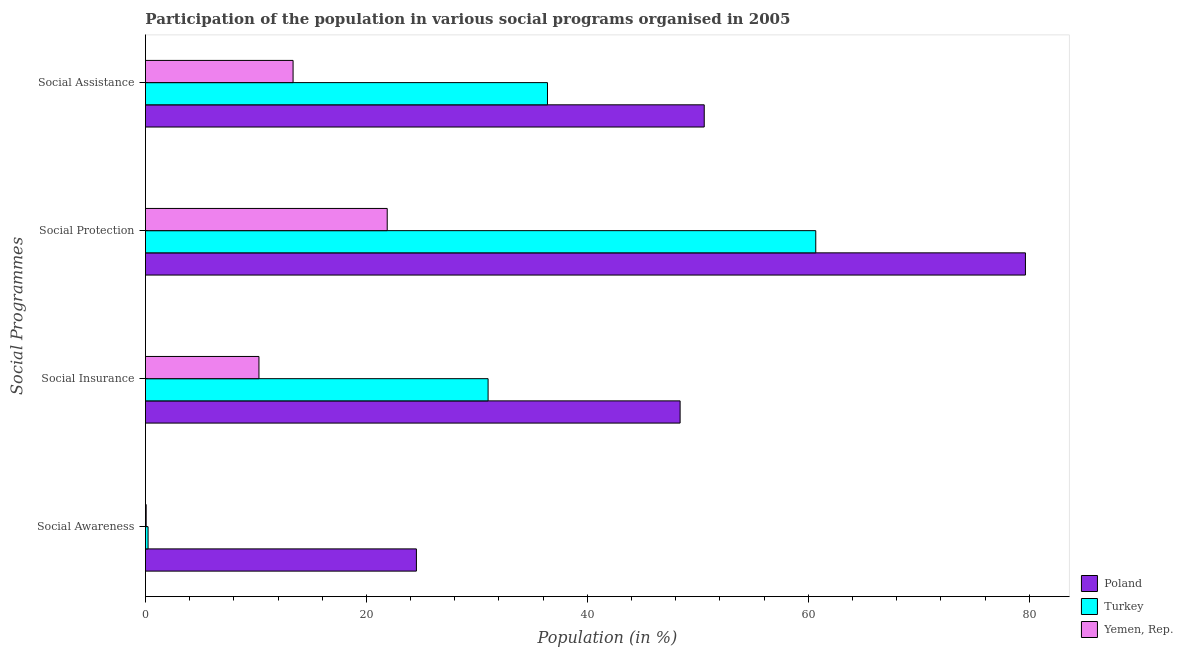How many different coloured bars are there?
Your answer should be compact. 3. How many bars are there on the 4th tick from the bottom?
Offer a terse response. 3. What is the label of the 3rd group of bars from the top?
Offer a very short reply. Social Insurance. What is the participation of population in social insurance programs in Yemen, Rep.?
Offer a terse response. 10.27. Across all countries, what is the maximum participation of population in social protection programs?
Offer a very short reply. 79.66. Across all countries, what is the minimum participation of population in social protection programs?
Your answer should be very brief. 21.88. In which country was the participation of population in social awareness programs maximum?
Offer a very short reply. Poland. In which country was the participation of population in social insurance programs minimum?
Give a very brief answer. Yemen, Rep. What is the total participation of population in social assistance programs in the graph?
Your response must be concise. 100.34. What is the difference between the participation of population in social protection programs in Turkey and that in Yemen, Rep.?
Offer a terse response. 38.79. What is the difference between the participation of population in social protection programs in Turkey and the participation of population in social assistance programs in Poland?
Offer a terse response. 10.1. What is the average participation of population in social protection programs per country?
Offer a very short reply. 54.07. What is the difference between the participation of population in social awareness programs and participation of population in social assistance programs in Turkey?
Your answer should be very brief. -36.15. What is the ratio of the participation of population in social protection programs in Yemen, Rep. to that in Poland?
Make the answer very short. 0.27. Is the participation of population in social protection programs in Turkey less than that in Yemen, Rep.?
Provide a short and direct response. No. Is the difference between the participation of population in social insurance programs in Yemen, Rep. and Turkey greater than the difference between the participation of population in social awareness programs in Yemen, Rep. and Turkey?
Make the answer very short. No. What is the difference between the highest and the second highest participation of population in social protection programs?
Give a very brief answer. 18.98. What is the difference between the highest and the lowest participation of population in social assistance programs?
Make the answer very short. 37.22. In how many countries, is the participation of population in social assistance programs greater than the average participation of population in social assistance programs taken over all countries?
Provide a short and direct response. 2. Is the sum of the participation of population in social protection programs in Yemen, Rep. and Turkey greater than the maximum participation of population in social insurance programs across all countries?
Provide a succinct answer. Yes. What does the 1st bar from the top in Social Insurance represents?
Provide a succinct answer. Yemen, Rep. What does the 1st bar from the bottom in Social Awareness represents?
Your response must be concise. Poland. Is it the case that in every country, the sum of the participation of population in social awareness programs and participation of population in social insurance programs is greater than the participation of population in social protection programs?
Ensure brevity in your answer.  No. How many bars are there?
Provide a succinct answer. 12. Does the graph contain grids?
Provide a succinct answer. No. Where does the legend appear in the graph?
Keep it short and to the point. Bottom right. How are the legend labels stacked?
Ensure brevity in your answer.  Vertical. What is the title of the graph?
Your response must be concise. Participation of the population in various social programs organised in 2005. Does "Zambia" appear as one of the legend labels in the graph?
Keep it short and to the point. No. What is the label or title of the X-axis?
Ensure brevity in your answer.  Population (in %). What is the label or title of the Y-axis?
Offer a terse response. Social Programmes. What is the Population (in %) of Poland in Social Awareness?
Your answer should be compact. 24.53. What is the Population (in %) in Turkey in Social Awareness?
Give a very brief answer. 0.24. What is the Population (in %) in Yemen, Rep. in Social Awareness?
Keep it short and to the point. 0.07. What is the Population (in %) in Poland in Social Insurance?
Keep it short and to the point. 48.4. What is the Population (in %) in Turkey in Social Insurance?
Provide a succinct answer. 31.02. What is the Population (in %) of Yemen, Rep. in Social Insurance?
Provide a short and direct response. 10.27. What is the Population (in %) of Poland in Social Protection?
Offer a terse response. 79.66. What is the Population (in %) in Turkey in Social Protection?
Your answer should be very brief. 60.68. What is the Population (in %) of Yemen, Rep. in Social Protection?
Your answer should be compact. 21.88. What is the Population (in %) of Poland in Social Assistance?
Offer a terse response. 50.58. What is the Population (in %) in Turkey in Social Assistance?
Offer a very short reply. 36.39. What is the Population (in %) of Yemen, Rep. in Social Assistance?
Your response must be concise. 13.36. Across all Social Programmes, what is the maximum Population (in %) of Poland?
Offer a terse response. 79.66. Across all Social Programmes, what is the maximum Population (in %) in Turkey?
Provide a succinct answer. 60.68. Across all Social Programmes, what is the maximum Population (in %) of Yemen, Rep.?
Your answer should be very brief. 21.88. Across all Social Programmes, what is the minimum Population (in %) of Poland?
Make the answer very short. 24.53. Across all Social Programmes, what is the minimum Population (in %) in Turkey?
Your answer should be compact. 0.24. Across all Social Programmes, what is the minimum Population (in %) of Yemen, Rep.?
Your answer should be very brief. 0.07. What is the total Population (in %) of Poland in the graph?
Keep it short and to the point. 203.17. What is the total Population (in %) of Turkey in the graph?
Give a very brief answer. 128.33. What is the total Population (in %) in Yemen, Rep. in the graph?
Provide a succinct answer. 45.59. What is the difference between the Population (in %) in Poland in Social Awareness and that in Social Insurance?
Your answer should be very brief. -23.87. What is the difference between the Population (in %) of Turkey in Social Awareness and that in Social Insurance?
Make the answer very short. -30.78. What is the difference between the Population (in %) in Yemen, Rep. in Social Awareness and that in Social Insurance?
Your answer should be very brief. -10.21. What is the difference between the Population (in %) of Poland in Social Awareness and that in Social Protection?
Ensure brevity in your answer.  -55.13. What is the difference between the Population (in %) in Turkey in Social Awareness and that in Social Protection?
Give a very brief answer. -60.44. What is the difference between the Population (in %) in Yemen, Rep. in Social Awareness and that in Social Protection?
Provide a succinct answer. -21.82. What is the difference between the Population (in %) of Poland in Social Awareness and that in Social Assistance?
Provide a succinct answer. -26.06. What is the difference between the Population (in %) of Turkey in Social Awareness and that in Social Assistance?
Make the answer very short. -36.15. What is the difference between the Population (in %) in Yemen, Rep. in Social Awareness and that in Social Assistance?
Your answer should be compact. -13.3. What is the difference between the Population (in %) of Poland in Social Insurance and that in Social Protection?
Make the answer very short. -31.26. What is the difference between the Population (in %) of Turkey in Social Insurance and that in Social Protection?
Keep it short and to the point. -29.66. What is the difference between the Population (in %) in Yemen, Rep. in Social Insurance and that in Social Protection?
Offer a terse response. -11.61. What is the difference between the Population (in %) in Poland in Social Insurance and that in Social Assistance?
Offer a very short reply. -2.18. What is the difference between the Population (in %) of Turkey in Social Insurance and that in Social Assistance?
Offer a very short reply. -5.38. What is the difference between the Population (in %) of Yemen, Rep. in Social Insurance and that in Social Assistance?
Make the answer very short. -3.09. What is the difference between the Population (in %) of Poland in Social Protection and that in Social Assistance?
Ensure brevity in your answer.  29.08. What is the difference between the Population (in %) of Turkey in Social Protection and that in Social Assistance?
Your answer should be compact. 24.29. What is the difference between the Population (in %) in Yemen, Rep. in Social Protection and that in Social Assistance?
Your answer should be compact. 8.52. What is the difference between the Population (in %) in Poland in Social Awareness and the Population (in %) in Turkey in Social Insurance?
Provide a succinct answer. -6.49. What is the difference between the Population (in %) of Poland in Social Awareness and the Population (in %) of Yemen, Rep. in Social Insurance?
Your answer should be compact. 14.25. What is the difference between the Population (in %) of Turkey in Social Awareness and the Population (in %) of Yemen, Rep. in Social Insurance?
Give a very brief answer. -10.04. What is the difference between the Population (in %) in Poland in Social Awareness and the Population (in %) in Turkey in Social Protection?
Ensure brevity in your answer.  -36.15. What is the difference between the Population (in %) in Poland in Social Awareness and the Population (in %) in Yemen, Rep. in Social Protection?
Offer a very short reply. 2.64. What is the difference between the Population (in %) in Turkey in Social Awareness and the Population (in %) in Yemen, Rep. in Social Protection?
Provide a short and direct response. -21.65. What is the difference between the Population (in %) in Poland in Social Awareness and the Population (in %) in Turkey in Social Assistance?
Offer a terse response. -11.87. What is the difference between the Population (in %) in Poland in Social Awareness and the Population (in %) in Yemen, Rep. in Social Assistance?
Make the answer very short. 11.16. What is the difference between the Population (in %) in Turkey in Social Awareness and the Population (in %) in Yemen, Rep. in Social Assistance?
Your answer should be very brief. -13.12. What is the difference between the Population (in %) in Poland in Social Insurance and the Population (in %) in Turkey in Social Protection?
Your response must be concise. -12.28. What is the difference between the Population (in %) in Poland in Social Insurance and the Population (in %) in Yemen, Rep. in Social Protection?
Your response must be concise. 26.51. What is the difference between the Population (in %) of Turkey in Social Insurance and the Population (in %) of Yemen, Rep. in Social Protection?
Make the answer very short. 9.13. What is the difference between the Population (in %) of Poland in Social Insurance and the Population (in %) of Turkey in Social Assistance?
Offer a terse response. 12.01. What is the difference between the Population (in %) of Poland in Social Insurance and the Population (in %) of Yemen, Rep. in Social Assistance?
Give a very brief answer. 35.04. What is the difference between the Population (in %) in Turkey in Social Insurance and the Population (in %) in Yemen, Rep. in Social Assistance?
Make the answer very short. 17.65. What is the difference between the Population (in %) of Poland in Social Protection and the Population (in %) of Turkey in Social Assistance?
Offer a terse response. 43.27. What is the difference between the Population (in %) in Poland in Social Protection and the Population (in %) in Yemen, Rep. in Social Assistance?
Provide a short and direct response. 66.3. What is the difference between the Population (in %) in Turkey in Social Protection and the Population (in %) in Yemen, Rep. in Social Assistance?
Ensure brevity in your answer.  47.32. What is the average Population (in %) of Poland per Social Programmes?
Your answer should be compact. 50.79. What is the average Population (in %) of Turkey per Social Programmes?
Offer a very short reply. 32.08. What is the average Population (in %) of Yemen, Rep. per Social Programmes?
Keep it short and to the point. 11.4. What is the difference between the Population (in %) in Poland and Population (in %) in Turkey in Social Awareness?
Your response must be concise. 24.29. What is the difference between the Population (in %) in Poland and Population (in %) in Yemen, Rep. in Social Awareness?
Give a very brief answer. 24.46. What is the difference between the Population (in %) of Turkey and Population (in %) of Yemen, Rep. in Social Awareness?
Provide a succinct answer. 0.17. What is the difference between the Population (in %) of Poland and Population (in %) of Turkey in Social Insurance?
Give a very brief answer. 17.38. What is the difference between the Population (in %) in Poland and Population (in %) in Yemen, Rep. in Social Insurance?
Provide a short and direct response. 38.12. What is the difference between the Population (in %) in Turkey and Population (in %) in Yemen, Rep. in Social Insurance?
Make the answer very short. 20.74. What is the difference between the Population (in %) in Poland and Population (in %) in Turkey in Social Protection?
Provide a succinct answer. 18.98. What is the difference between the Population (in %) of Poland and Population (in %) of Yemen, Rep. in Social Protection?
Make the answer very short. 57.77. What is the difference between the Population (in %) of Turkey and Population (in %) of Yemen, Rep. in Social Protection?
Ensure brevity in your answer.  38.79. What is the difference between the Population (in %) of Poland and Population (in %) of Turkey in Social Assistance?
Provide a short and direct response. 14.19. What is the difference between the Population (in %) in Poland and Population (in %) in Yemen, Rep. in Social Assistance?
Offer a very short reply. 37.22. What is the difference between the Population (in %) in Turkey and Population (in %) in Yemen, Rep. in Social Assistance?
Keep it short and to the point. 23.03. What is the ratio of the Population (in %) of Poland in Social Awareness to that in Social Insurance?
Offer a terse response. 0.51. What is the ratio of the Population (in %) in Turkey in Social Awareness to that in Social Insurance?
Make the answer very short. 0.01. What is the ratio of the Population (in %) of Yemen, Rep. in Social Awareness to that in Social Insurance?
Ensure brevity in your answer.  0.01. What is the ratio of the Population (in %) of Poland in Social Awareness to that in Social Protection?
Give a very brief answer. 0.31. What is the ratio of the Population (in %) in Turkey in Social Awareness to that in Social Protection?
Ensure brevity in your answer.  0. What is the ratio of the Population (in %) of Yemen, Rep. in Social Awareness to that in Social Protection?
Your answer should be very brief. 0. What is the ratio of the Population (in %) in Poland in Social Awareness to that in Social Assistance?
Your response must be concise. 0.48. What is the ratio of the Population (in %) of Turkey in Social Awareness to that in Social Assistance?
Keep it short and to the point. 0.01. What is the ratio of the Population (in %) of Yemen, Rep. in Social Awareness to that in Social Assistance?
Provide a succinct answer. 0. What is the ratio of the Population (in %) of Poland in Social Insurance to that in Social Protection?
Provide a short and direct response. 0.61. What is the ratio of the Population (in %) in Turkey in Social Insurance to that in Social Protection?
Your response must be concise. 0.51. What is the ratio of the Population (in %) of Yemen, Rep. in Social Insurance to that in Social Protection?
Give a very brief answer. 0.47. What is the ratio of the Population (in %) in Poland in Social Insurance to that in Social Assistance?
Provide a short and direct response. 0.96. What is the ratio of the Population (in %) of Turkey in Social Insurance to that in Social Assistance?
Keep it short and to the point. 0.85. What is the ratio of the Population (in %) of Yemen, Rep. in Social Insurance to that in Social Assistance?
Make the answer very short. 0.77. What is the ratio of the Population (in %) in Poland in Social Protection to that in Social Assistance?
Give a very brief answer. 1.57. What is the ratio of the Population (in %) of Turkey in Social Protection to that in Social Assistance?
Your answer should be compact. 1.67. What is the ratio of the Population (in %) of Yemen, Rep. in Social Protection to that in Social Assistance?
Ensure brevity in your answer.  1.64. What is the difference between the highest and the second highest Population (in %) of Poland?
Make the answer very short. 29.08. What is the difference between the highest and the second highest Population (in %) in Turkey?
Ensure brevity in your answer.  24.29. What is the difference between the highest and the second highest Population (in %) of Yemen, Rep.?
Make the answer very short. 8.52. What is the difference between the highest and the lowest Population (in %) of Poland?
Your answer should be very brief. 55.13. What is the difference between the highest and the lowest Population (in %) of Turkey?
Provide a short and direct response. 60.44. What is the difference between the highest and the lowest Population (in %) of Yemen, Rep.?
Offer a very short reply. 21.82. 